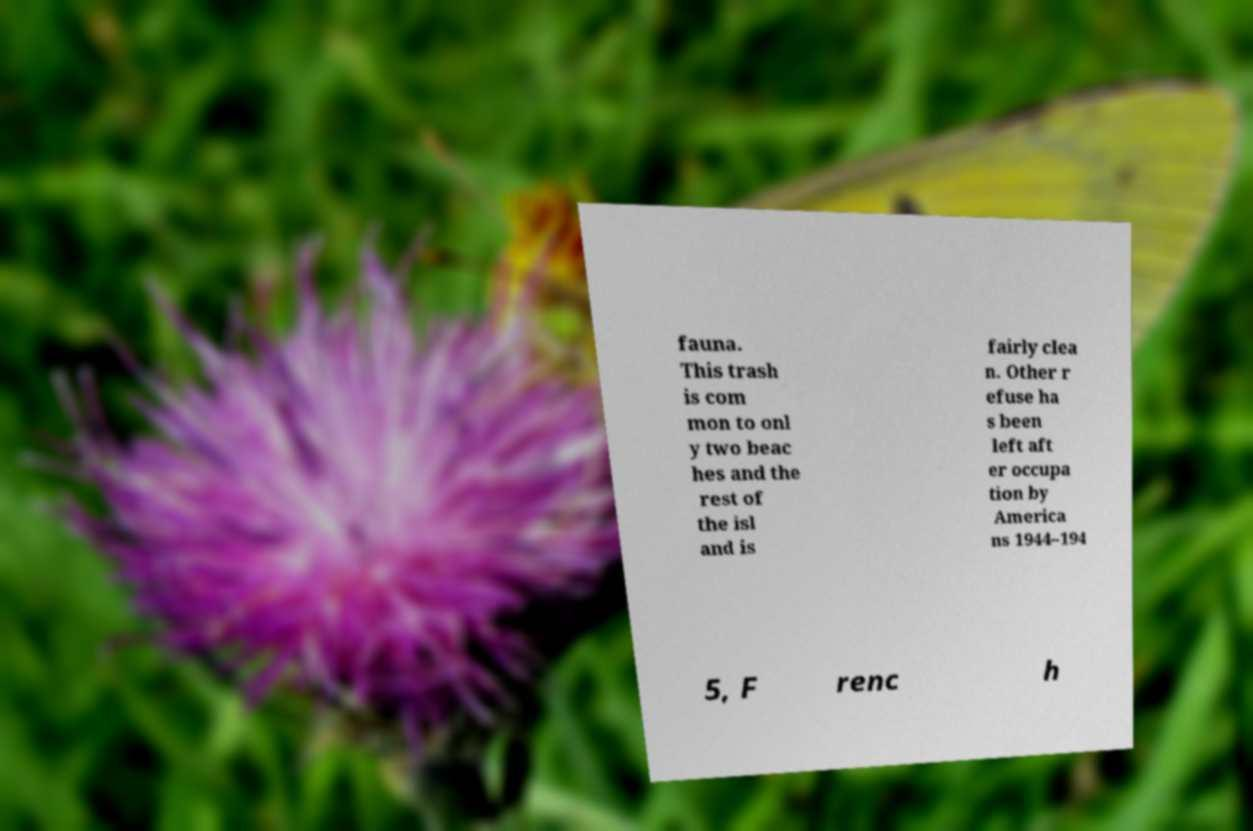For documentation purposes, I need the text within this image transcribed. Could you provide that? fauna. This trash is com mon to onl y two beac hes and the rest of the isl and is fairly clea n. Other r efuse ha s been left aft er occupa tion by America ns 1944–194 5, F renc h 